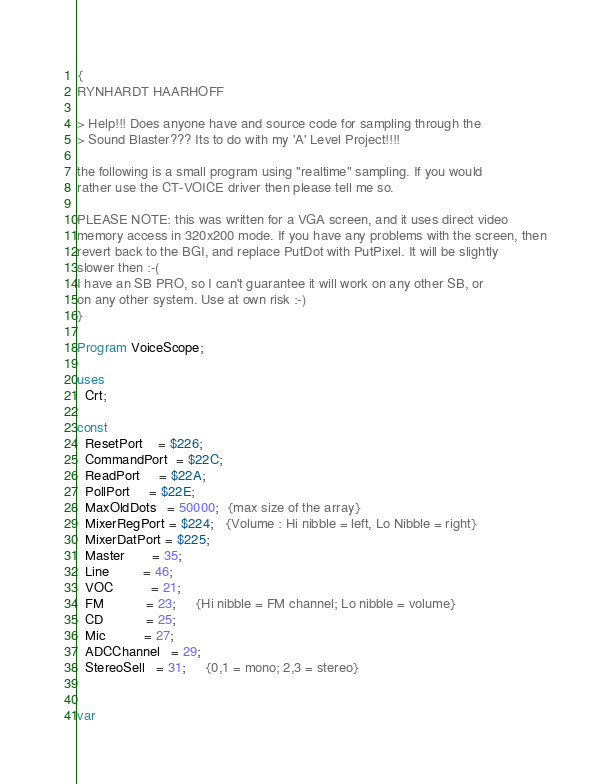<code> <loc_0><loc_0><loc_500><loc_500><_Pascal_>{
RYNHARDT HAARHOFF

> Help!!! Does anyone have and source code for sampling through the
> Sound Blaster??? Its to do with my 'A' Level Project!!!!

the following is a small program using "realtime" sampling. If you would
rather use the CT-VOICE driver then please tell me so.

PLEASE NOTE: this was written for a VGA screen, and it uses direct video
memory access in 320x200 mode. If you have any problems with the screen, then
revert back to the BGI, and replace PutDot with PutPixel. It will be slightly
slower then :-(
I have an SB PRO, so I can't guarantee it will work on any other SB, or
on any other system. Use at own risk :-)
}

Program VoiceScope;

uses
  Crt;

const
  ResetPort    = $226;
  CommandPort  = $22C;
  ReadPort     = $22A;
  PollPort     = $22E;
  MaxOldDots   = 50000;  {max size of the array}
  MixerRegPort = $224;   {Volume : Hi nibble = left, Lo Nibble = right}
  MixerDatPort = $225;
  Master       = 35;
  Line         = 46;
  VOC          = 21;
  FM           = 23;     {Hi nibble = FM channel; Lo nibble = volume}
  CD           = 25;
  Mic          = 27;
  ADCChannel   = 29;
  StereoSell   = 31;     {0,1 = mono; 2,3 = stereo}


var</code> 